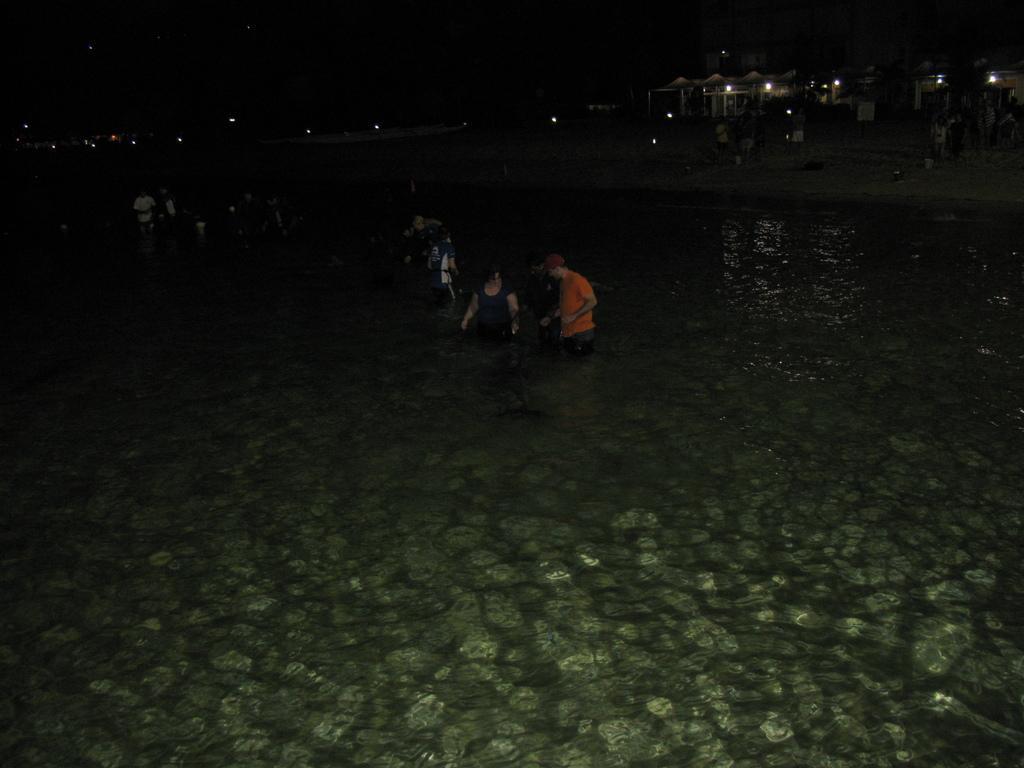In one or two sentences, can you explain what this image depicts? In this picture we can see water at the bottom, there are some people standing, in the background we can see buildings and lights, there is a dark background. 